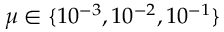Convert formula to latex. <formula><loc_0><loc_0><loc_500><loc_500>\mu \in \{ 1 0 ^ { - 3 } , 1 0 ^ { - 2 } , 1 0 ^ { - 1 } \}</formula> 